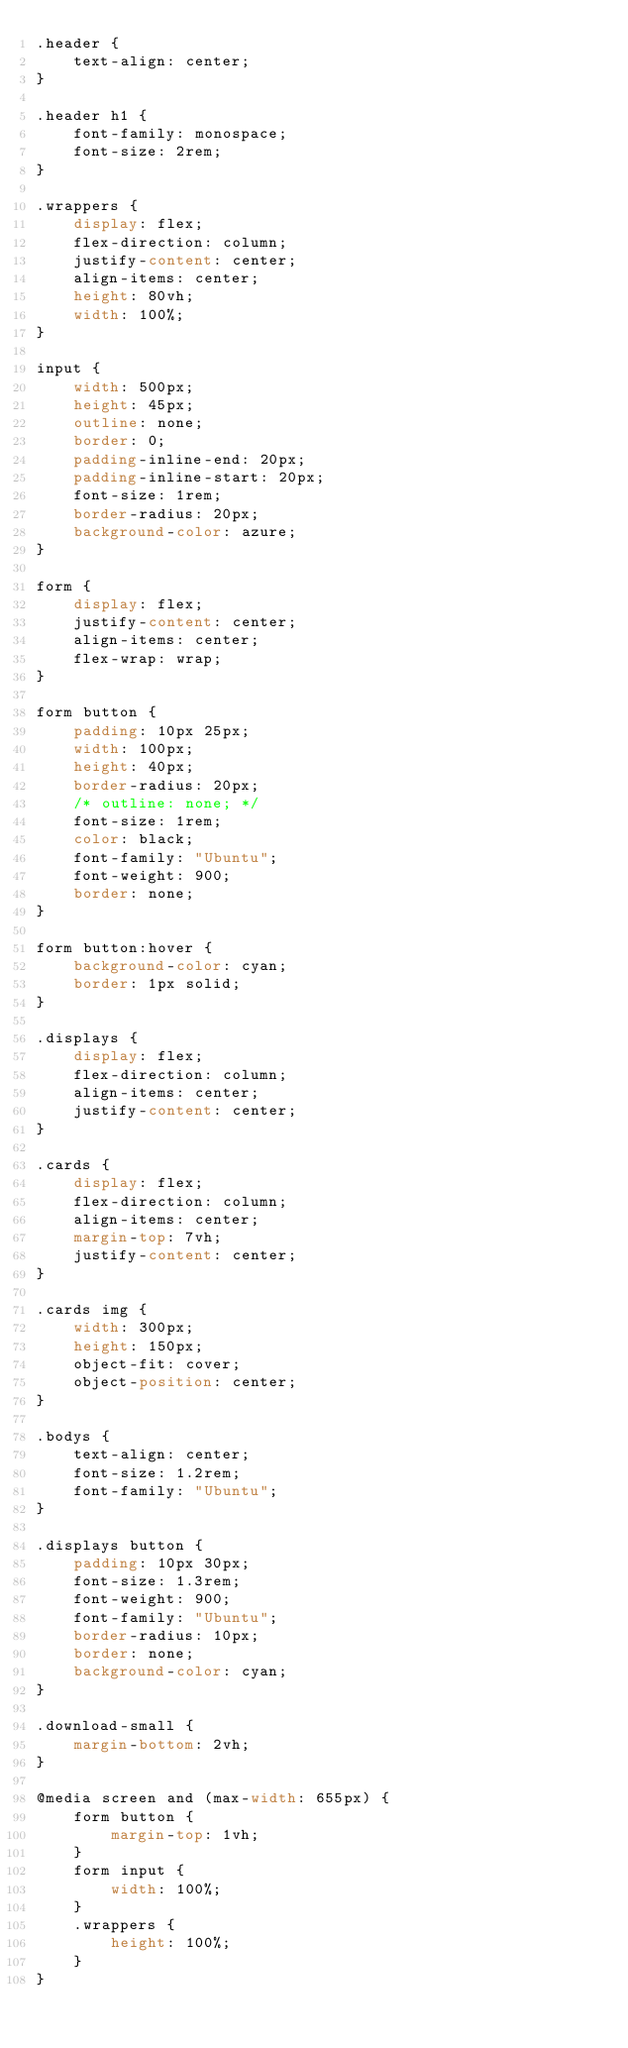Convert code to text. <code><loc_0><loc_0><loc_500><loc_500><_CSS_>.header {
    text-align: center;
}

.header h1 {
    font-family: monospace;
    font-size: 2rem;
}

.wrappers {
    display: flex;
    flex-direction: column;
    justify-content: center;
    align-items: center;
    height: 80vh;
    width: 100%;
}

input {
    width: 500px;
    height: 45px;
    outline: none;
    border: 0;
    padding-inline-end: 20px;
    padding-inline-start: 20px;
    font-size: 1rem;
    border-radius: 20px;
    background-color: azure;
}

form {
    display: flex;
    justify-content: center;
    align-items: center;
    flex-wrap: wrap;
}

form button {
    padding: 10px 25px;
    width: 100px;
    height: 40px;
    border-radius: 20px;
    /* outline: none; */
    font-size: 1rem;
    color: black;
    font-family: "Ubuntu";
    font-weight: 900;
    border: none;
}

form button:hover {
    background-color: cyan;
    border: 1px solid;
}

.displays {
    display: flex;
    flex-direction: column;
    align-items: center;
    justify-content: center;
}

.cards {
    display: flex;
    flex-direction: column;
    align-items: center;
    margin-top: 7vh;
    justify-content: center;
}

.cards img {
    width: 300px;
    height: 150px;
    object-fit: cover;
    object-position: center;
}

.bodys {
    text-align: center;
    font-size: 1.2rem;
    font-family: "Ubuntu";
}

.displays button {
    padding: 10px 30px;
    font-size: 1.3rem;
    font-weight: 900;
    font-family: "Ubuntu";
    border-radius: 10px;
    border: none;
    background-color: cyan;
}

.download-small {
    margin-bottom: 2vh;
}

@media screen and (max-width: 655px) {
    form button {
        margin-top: 1vh;
    }
    form input {
        width: 100%;
    }
    .wrappers {
        height: 100%;
    }
}</code> 